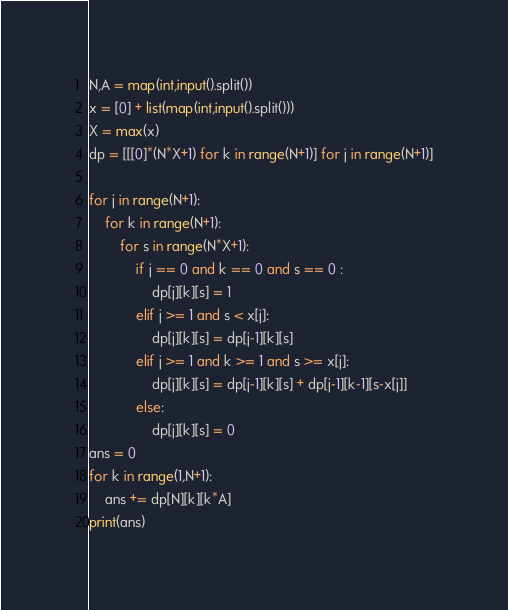<code> <loc_0><loc_0><loc_500><loc_500><_Python_>N,A = map(int,input().split())
x = [0] + list(map(int,input().split()))
X = max(x)
dp = [[[0]*(N*X+1) for k in range(N+1)] for j in range(N+1)]

for j in range(N+1):
    for k in range(N+1):
        for s in range(N*X+1):
            if j == 0 and k == 0 and s == 0 :
                dp[j][k][s] = 1
            elif j >= 1 and s < x[j]:
                dp[j][k][s] = dp[j-1][k][s]
            elif j >= 1 and k >= 1 and s >= x[j]:
                dp[j][k][s] = dp[j-1][k][s] + dp[j-1][k-1][s-x[j]]
            else:
                dp[j][k][s] = 0
ans = 0
for k in range(1,N+1):
    ans += dp[N][k][k*A]
print(ans)</code> 